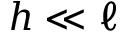Convert formula to latex. <formula><loc_0><loc_0><loc_500><loc_500>h \ll \ell</formula> 